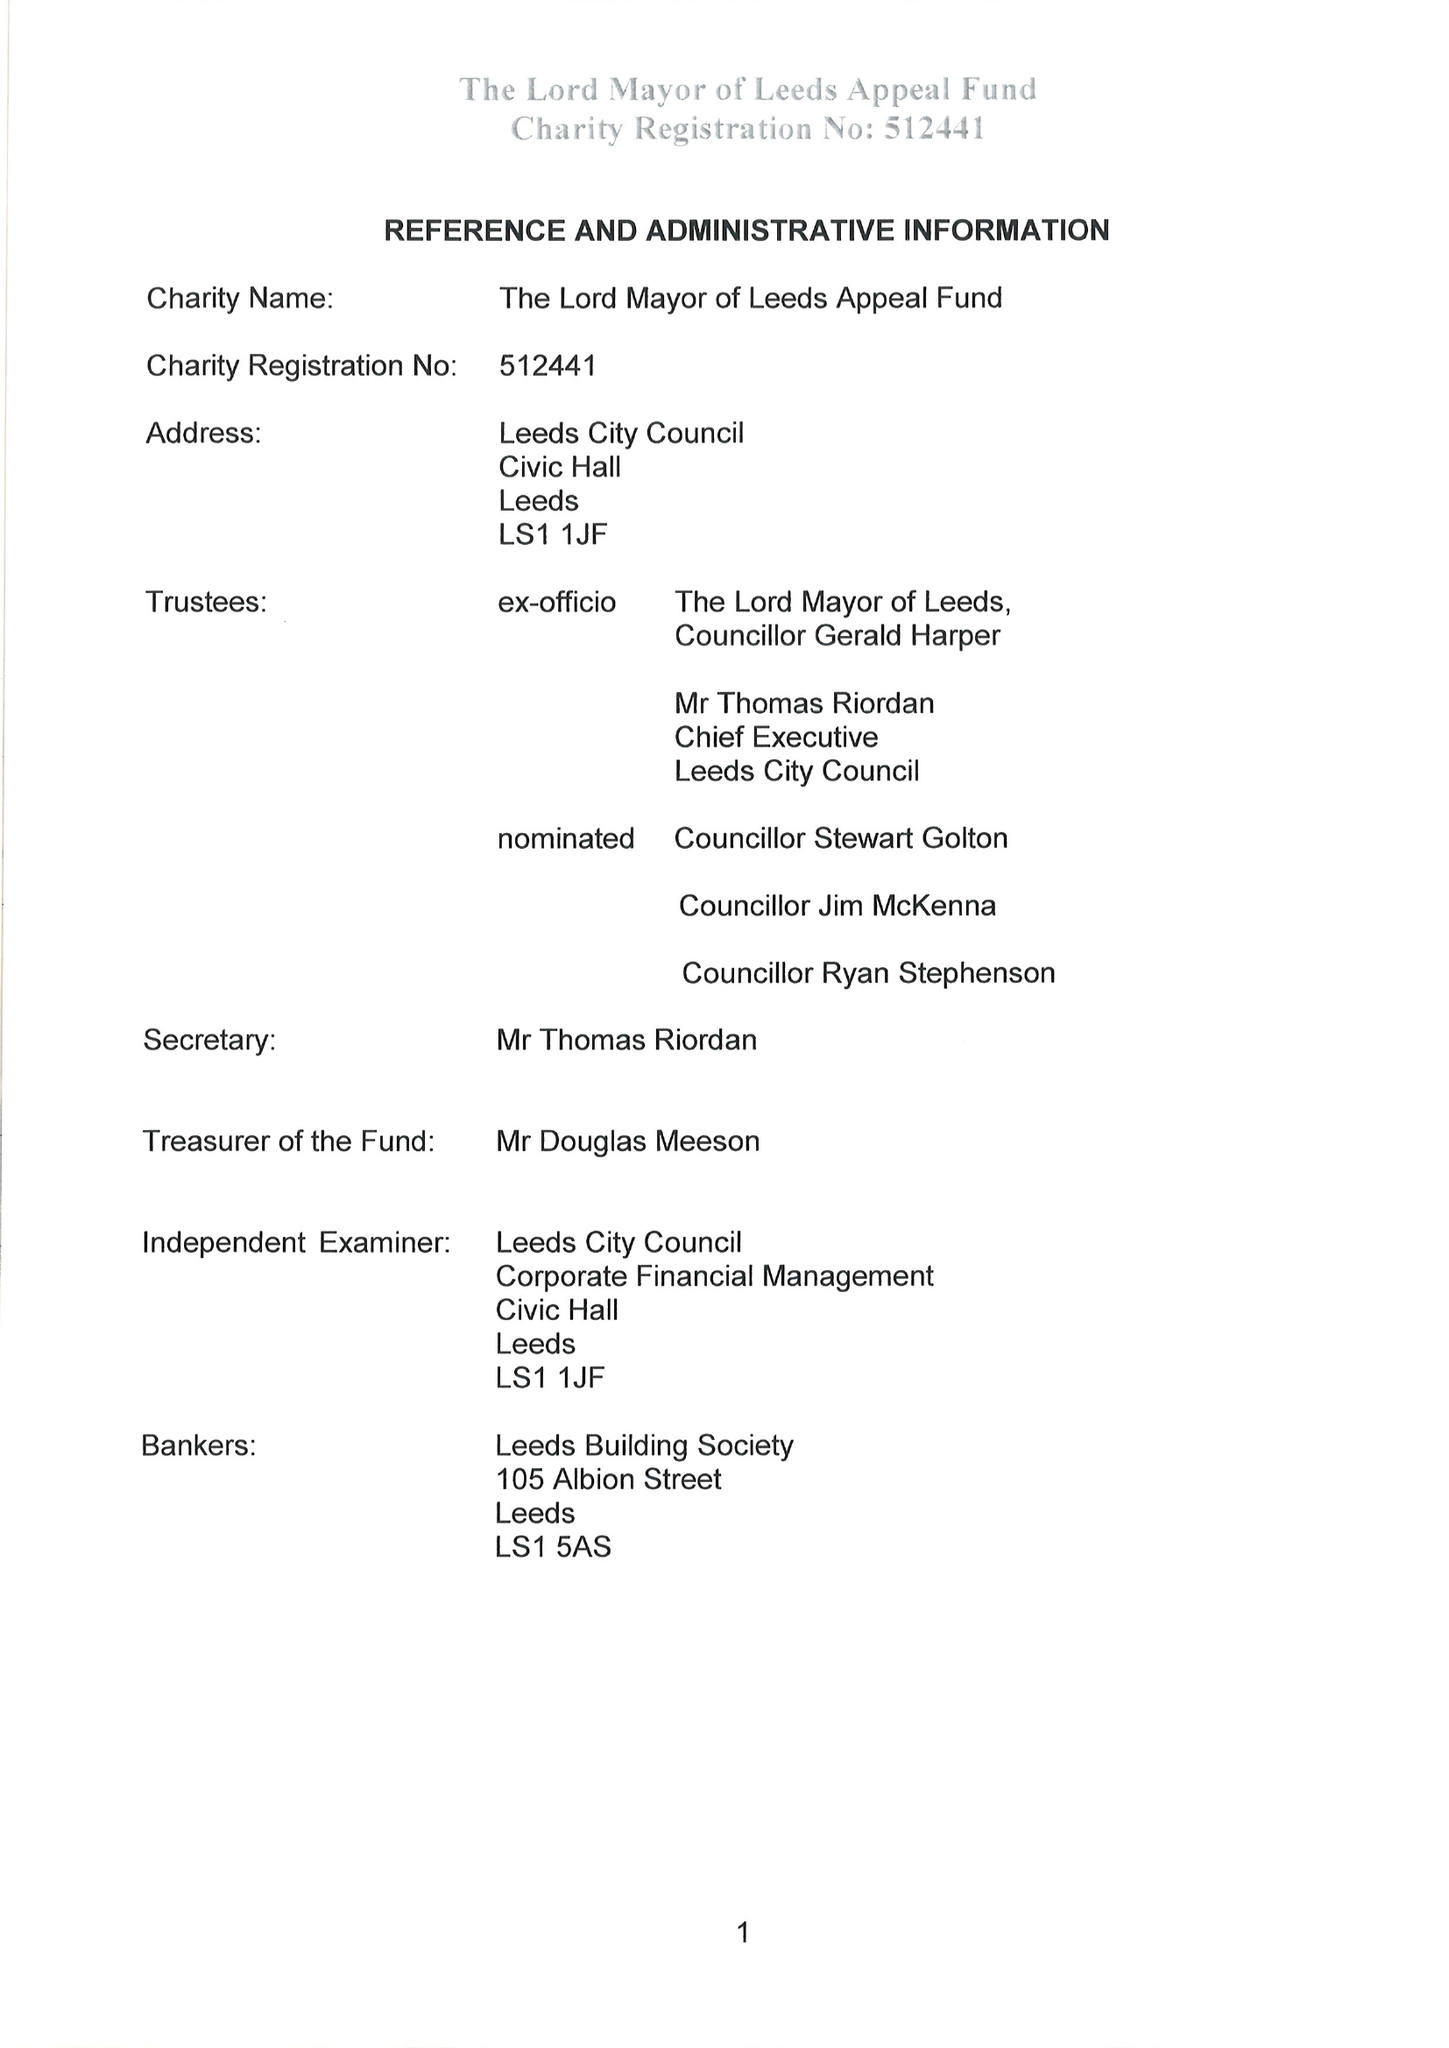What is the value for the charity_number?
Answer the question using a single word or phrase. 512441 